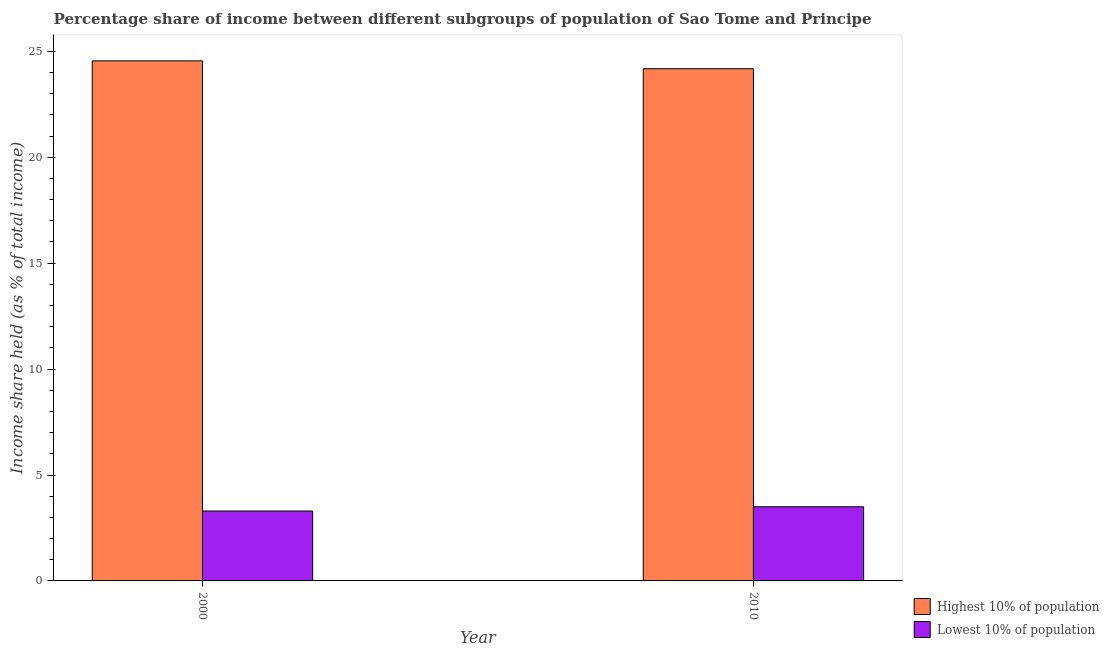How many different coloured bars are there?
Provide a short and direct response. 2. Are the number of bars per tick equal to the number of legend labels?
Provide a short and direct response. Yes. Are the number of bars on each tick of the X-axis equal?
Offer a very short reply. Yes. How many bars are there on the 1st tick from the left?
Offer a terse response. 2. What is the label of the 2nd group of bars from the left?
Make the answer very short. 2010. What is the income share held by highest 10% of the population in 2010?
Your answer should be very brief. 24.18. Across all years, what is the maximum income share held by highest 10% of the population?
Your answer should be compact. 24.55. In which year was the income share held by lowest 10% of the population maximum?
Provide a short and direct response. 2010. In which year was the income share held by highest 10% of the population minimum?
Ensure brevity in your answer.  2010. What is the total income share held by highest 10% of the population in the graph?
Make the answer very short. 48.73. What is the difference between the income share held by lowest 10% of the population in 2000 and that in 2010?
Give a very brief answer. -0.2. What is the difference between the income share held by highest 10% of the population in 2010 and the income share held by lowest 10% of the population in 2000?
Your response must be concise. -0.37. In the year 2010, what is the difference between the income share held by highest 10% of the population and income share held by lowest 10% of the population?
Provide a short and direct response. 0. In how many years, is the income share held by highest 10% of the population greater than 13 %?
Provide a short and direct response. 2. What is the ratio of the income share held by highest 10% of the population in 2000 to that in 2010?
Ensure brevity in your answer.  1.02. In how many years, is the income share held by highest 10% of the population greater than the average income share held by highest 10% of the population taken over all years?
Make the answer very short. 1. What does the 2nd bar from the left in 2010 represents?
Make the answer very short. Lowest 10% of population. What does the 2nd bar from the right in 2000 represents?
Keep it short and to the point. Highest 10% of population. Does the graph contain any zero values?
Offer a terse response. No. Does the graph contain grids?
Your answer should be very brief. No. Where does the legend appear in the graph?
Provide a succinct answer. Bottom right. How many legend labels are there?
Your answer should be very brief. 2. How are the legend labels stacked?
Offer a very short reply. Vertical. What is the title of the graph?
Offer a very short reply. Percentage share of income between different subgroups of population of Sao Tome and Principe. Does "Depositors" appear as one of the legend labels in the graph?
Your response must be concise. No. What is the label or title of the X-axis?
Your answer should be compact. Year. What is the label or title of the Y-axis?
Provide a succinct answer. Income share held (as % of total income). What is the Income share held (as % of total income) of Highest 10% of population in 2000?
Offer a very short reply. 24.55. What is the Income share held (as % of total income) in Highest 10% of population in 2010?
Make the answer very short. 24.18. Across all years, what is the maximum Income share held (as % of total income) in Highest 10% of population?
Your response must be concise. 24.55. Across all years, what is the maximum Income share held (as % of total income) in Lowest 10% of population?
Your answer should be very brief. 3.5. Across all years, what is the minimum Income share held (as % of total income) of Highest 10% of population?
Give a very brief answer. 24.18. What is the total Income share held (as % of total income) in Highest 10% of population in the graph?
Give a very brief answer. 48.73. What is the difference between the Income share held (as % of total income) of Highest 10% of population in 2000 and that in 2010?
Keep it short and to the point. 0.37. What is the difference between the Income share held (as % of total income) in Highest 10% of population in 2000 and the Income share held (as % of total income) in Lowest 10% of population in 2010?
Your answer should be very brief. 21.05. What is the average Income share held (as % of total income) in Highest 10% of population per year?
Give a very brief answer. 24.36. What is the average Income share held (as % of total income) in Lowest 10% of population per year?
Your answer should be compact. 3.4. In the year 2000, what is the difference between the Income share held (as % of total income) in Highest 10% of population and Income share held (as % of total income) in Lowest 10% of population?
Provide a short and direct response. 21.25. In the year 2010, what is the difference between the Income share held (as % of total income) in Highest 10% of population and Income share held (as % of total income) in Lowest 10% of population?
Offer a terse response. 20.68. What is the ratio of the Income share held (as % of total income) in Highest 10% of population in 2000 to that in 2010?
Provide a succinct answer. 1.02. What is the ratio of the Income share held (as % of total income) of Lowest 10% of population in 2000 to that in 2010?
Make the answer very short. 0.94. What is the difference between the highest and the second highest Income share held (as % of total income) in Highest 10% of population?
Ensure brevity in your answer.  0.37. What is the difference between the highest and the second highest Income share held (as % of total income) in Lowest 10% of population?
Your answer should be very brief. 0.2. What is the difference between the highest and the lowest Income share held (as % of total income) in Highest 10% of population?
Your answer should be compact. 0.37. 